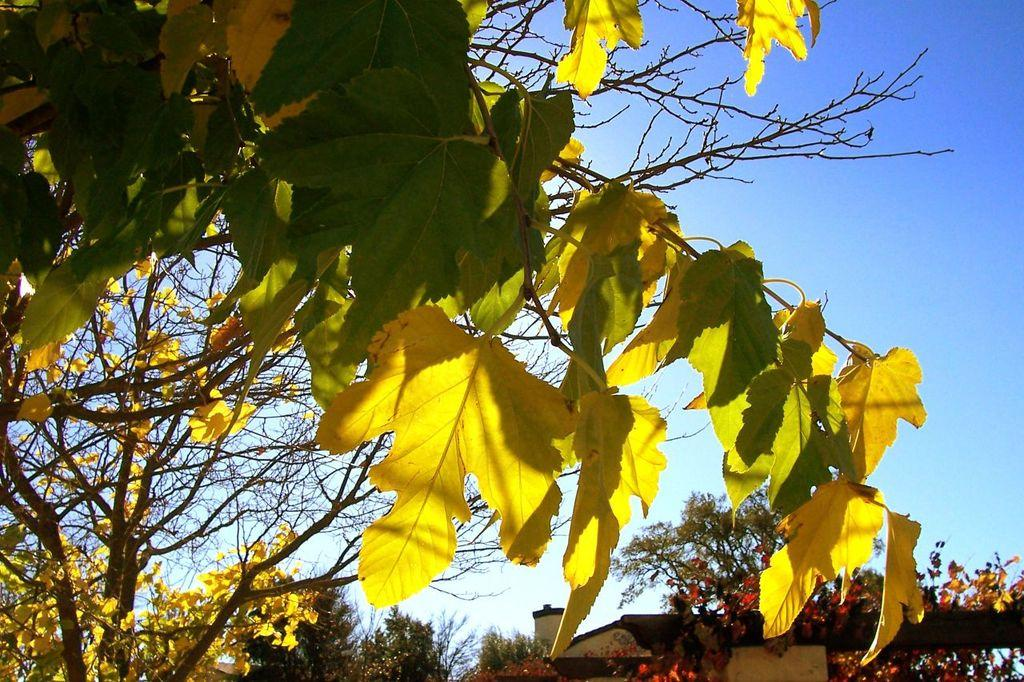What type of living organisms can be seen in the image? Plants can be seen in the image. What structure is located in the image? There is a house in the image. Where is the house positioned in the image? The house is in the middle of the image. What is visible above the house in the image? The sky is visible above the house in the image. Can you tell me how many cars the writer is looking at with their eye in the image? There are no cars, writer, or eye present in the image. 